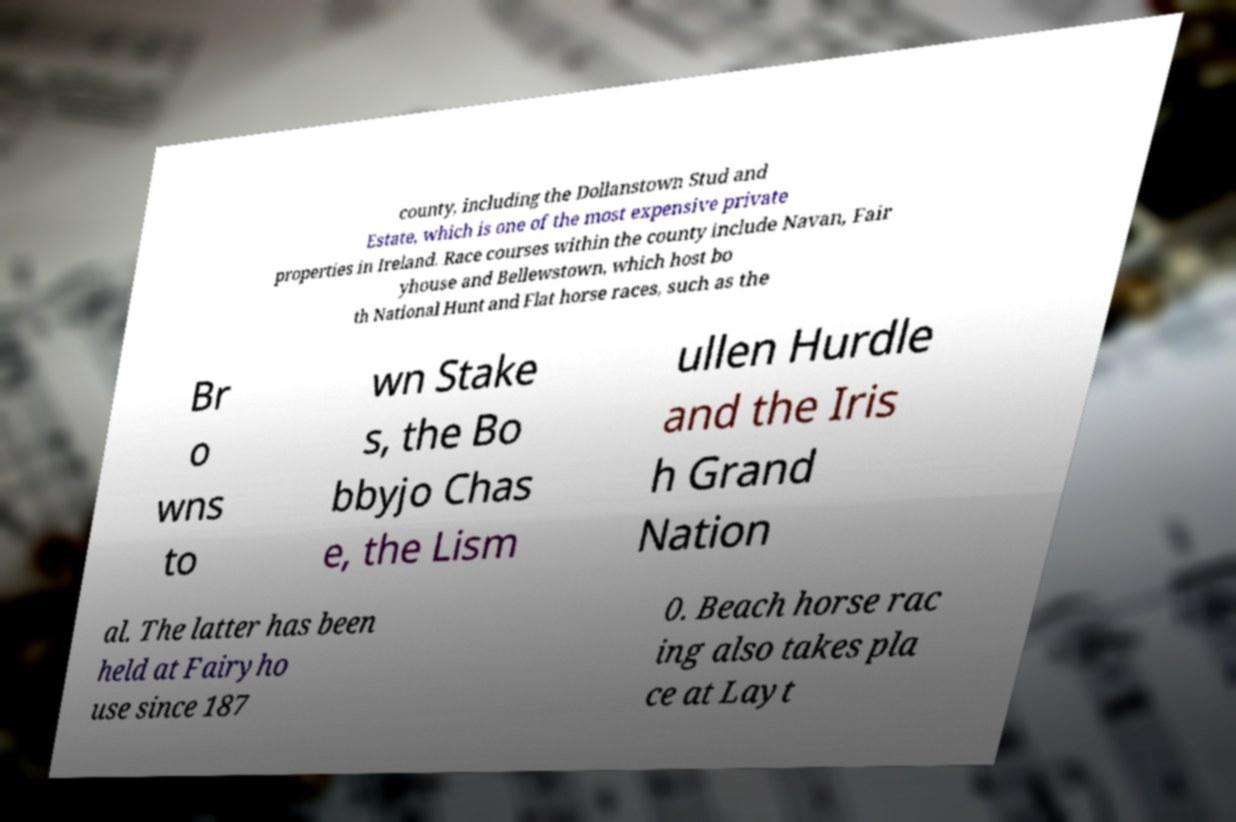Can you read and provide the text displayed in the image?This photo seems to have some interesting text. Can you extract and type it out for me? county, including the Dollanstown Stud and Estate, which is one of the most expensive private properties in Ireland. Race courses within the county include Navan, Fair yhouse and Bellewstown, which host bo th National Hunt and Flat horse races, such as the Br o wns to wn Stake s, the Bo bbyjo Chas e, the Lism ullen Hurdle and the Iris h Grand Nation al. The latter has been held at Fairyho use since 187 0. Beach horse rac ing also takes pla ce at Layt 